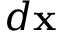Convert formula to latex. <formula><loc_0><loc_0><loc_500><loc_500>d x</formula> 